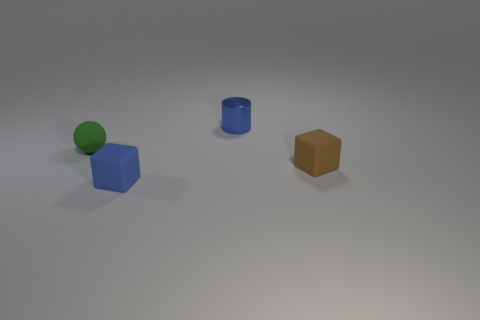Add 4 purple metal things. How many objects exist? 8 Subtract all balls. How many objects are left? 3 Subtract 1 green balls. How many objects are left? 3 Subtract all big green cylinders. Subtract all tiny blue metallic things. How many objects are left? 3 Add 2 small green rubber objects. How many small green rubber objects are left? 3 Add 2 blue objects. How many blue objects exist? 4 